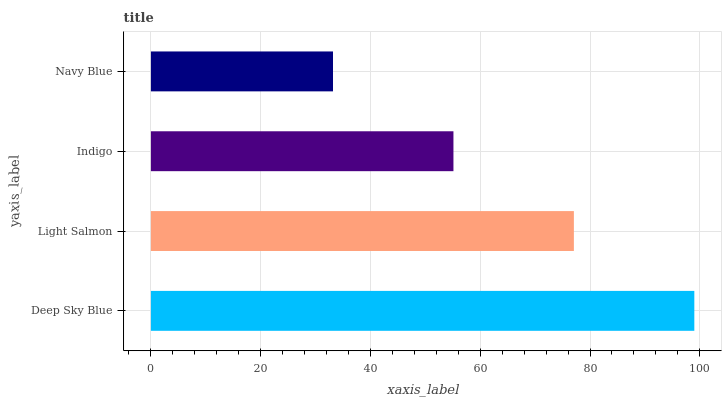Is Navy Blue the minimum?
Answer yes or no. Yes. Is Deep Sky Blue the maximum?
Answer yes or no. Yes. Is Light Salmon the minimum?
Answer yes or no. No. Is Light Salmon the maximum?
Answer yes or no. No. Is Deep Sky Blue greater than Light Salmon?
Answer yes or no. Yes. Is Light Salmon less than Deep Sky Blue?
Answer yes or no. Yes. Is Light Salmon greater than Deep Sky Blue?
Answer yes or no. No. Is Deep Sky Blue less than Light Salmon?
Answer yes or no. No. Is Light Salmon the high median?
Answer yes or no. Yes. Is Indigo the low median?
Answer yes or no. Yes. Is Navy Blue the high median?
Answer yes or no. No. Is Navy Blue the low median?
Answer yes or no. No. 